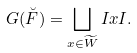<formula> <loc_0><loc_0><loc_500><loc_500>G ( \breve { F } ) = \bigsqcup _ { x \in \widetilde { W } } I x I .</formula> 